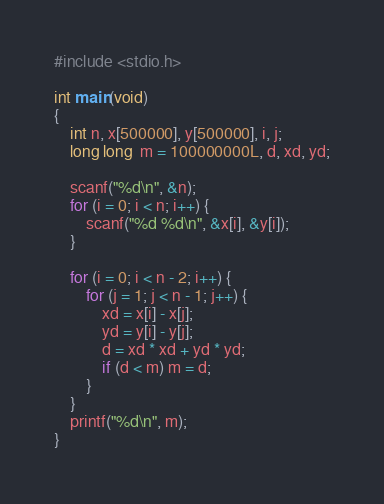<code> <loc_0><loc_0><loc_500><loc_500><_C_>#include <stdio.h>

int main(void)
{
    int n, x[500000], y[500000], i, j;
    long long  m = 100000000L, d, xd, yd;

    scanf("%d\n", &n);
    for (i = 0; i < n; i++) {
        scanf("%d %d\n", &x[i], &y[i]);
    }

    for (i = 0; i < n - 2; i++) {
        for (j = 1; j < n - 1; j++) {
            xd = x[i] - x[j];
            yd = y[i] - y[j];
            d = xd * xd + yd * yd;
            if (d < m) m = d;
        }
    }
    printf("%d\n", m);
}

</code> 